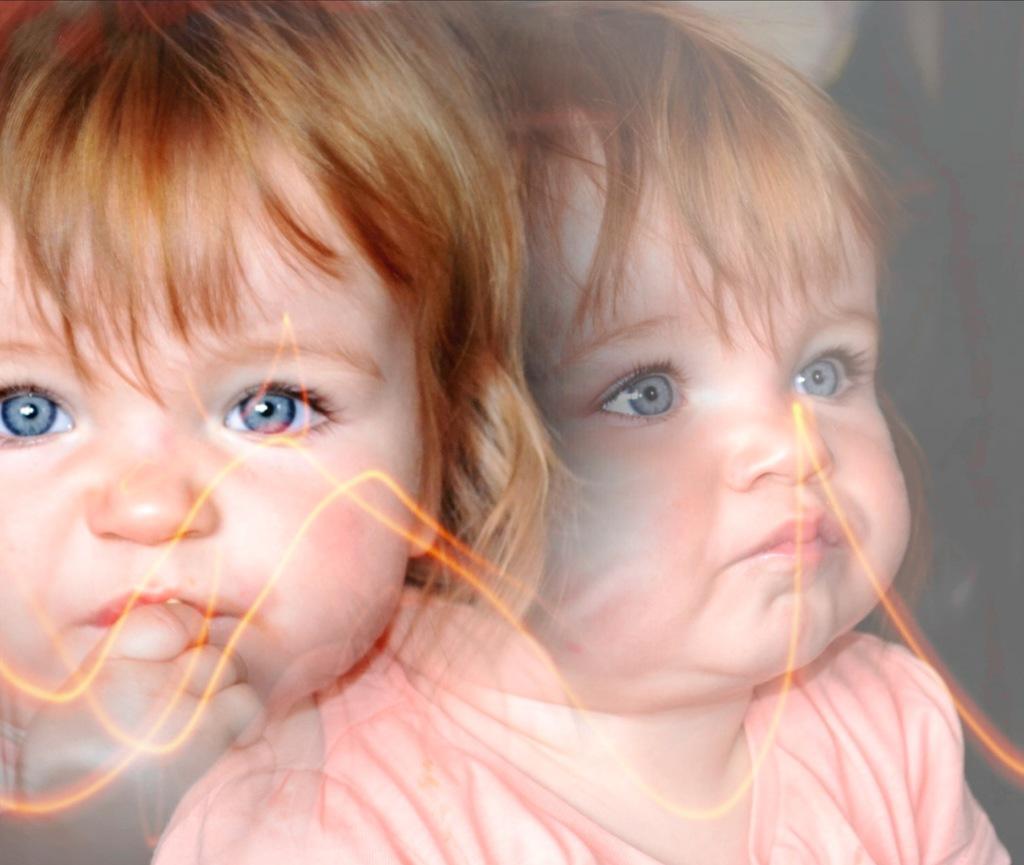Can you describe this image briefly? In the image we can see there is a picture of a child and she is putting finger on her lip. 